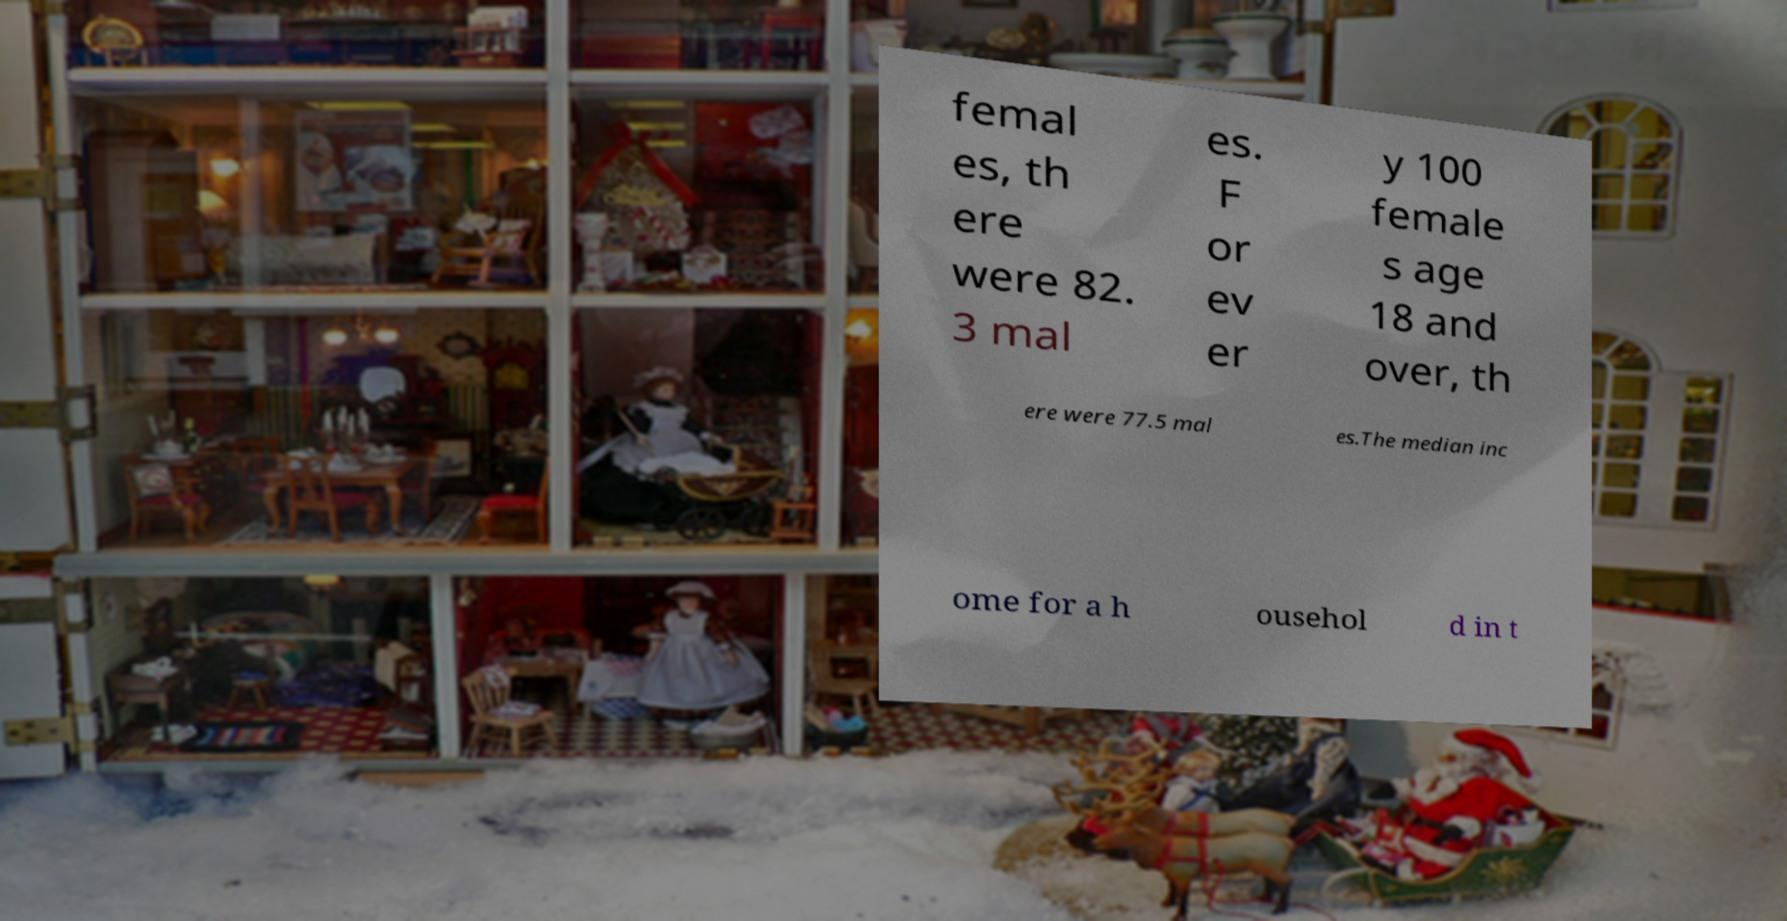There's text embedded in this image that I need extracted. Can you transcribe it verbatim? femal es, th ere were 82. 3 mal es. F or ev er y 100 female s age 18 and over, th ere were 77.5 mal es.The median inc ome for a h ousehol d in t 